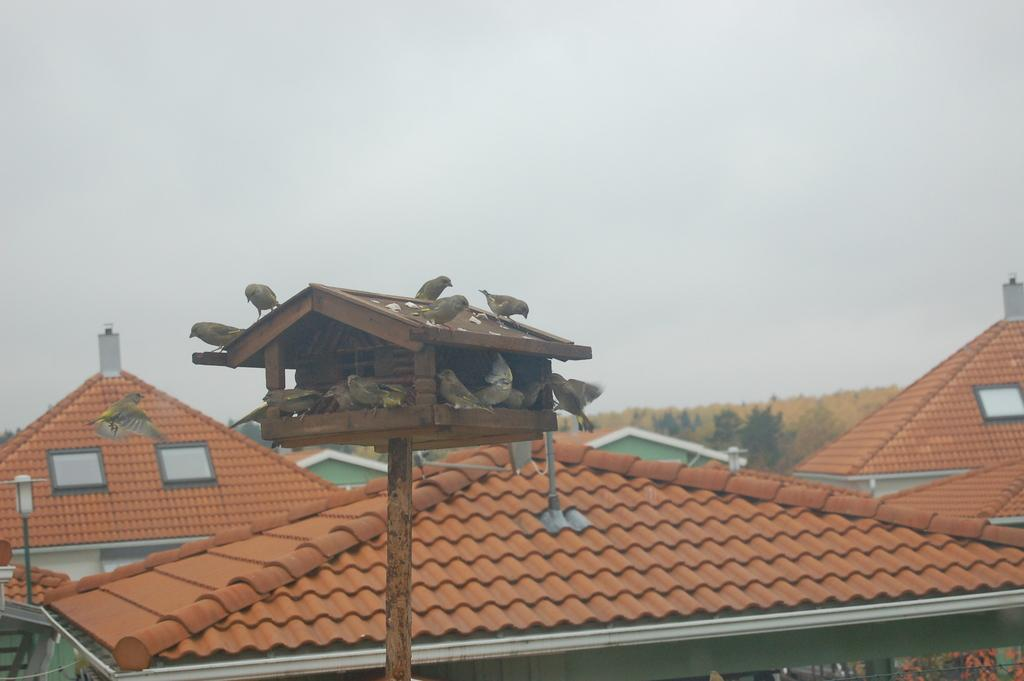What type of structure is present in the image? There is a bird house in the image. What animals can be seen in the image? There are birds in the image. What other object is present in the image? There is a light pole in the image. What type of buildings are visible in the image? Rooftops of houses are visible in the image. What can be seen in the background of the image? There are trees and the sky visible in the background of the image. Can you tell me how many clams are sitting on the roof of the bird house in the image? There are no clams present in the image; it features a bird house, birds, a light pole, rooftops of houses, trees, and the sky. What type of nose is visible on the birds in the image? Birds do not have noses like humans; they have a beak for breathing and eating. 